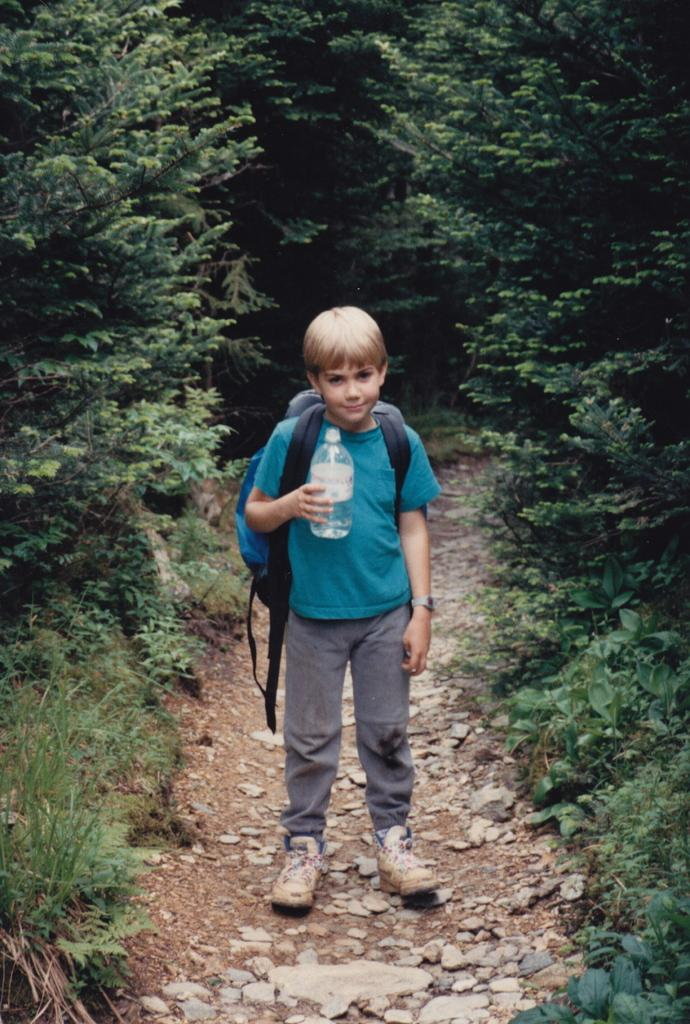Who or what is present in the image? There is a person in the image. Can you describe the setting of the image? The person is standing between trees. What is the person carrying on their back? The person is wearing a backpack. What is the person holding in their hand? The person is holding a water bottle. What type of cake is being invented by the person in the image? There is no cake or invention present in the image; it features a person standing between trees while wearing a backpack and holding a water bottle. Can you describe the person's eye color in the image? The provided facts do not mention the person's eye color, so it cannot be determined from the image. 